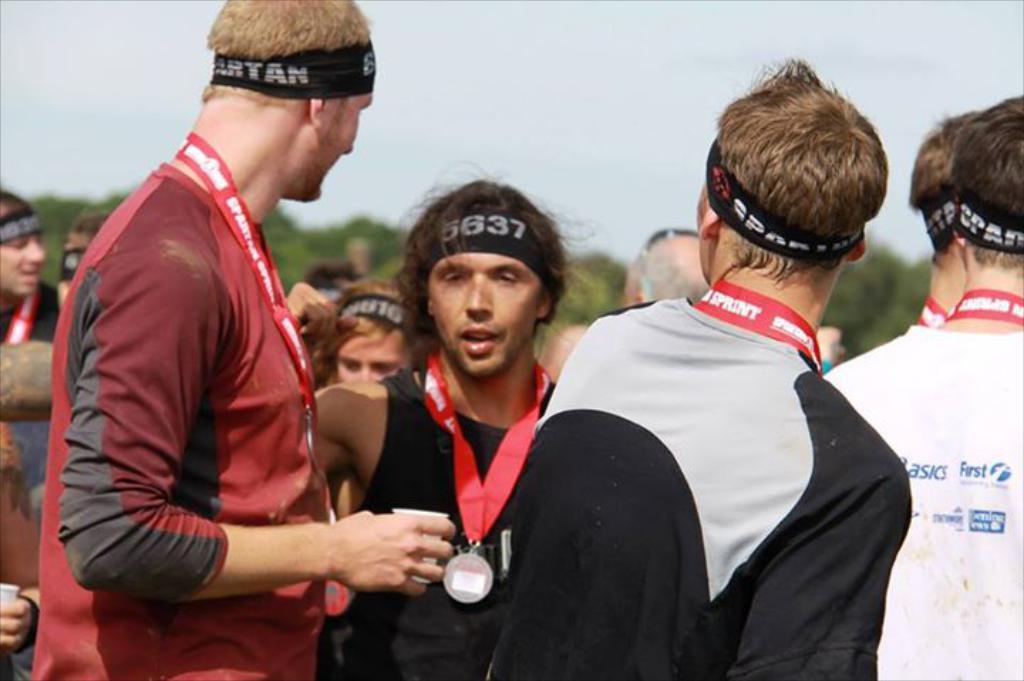Could you give a brief overview of what you see in this image? In the image there are a group of men and they are wearing bands to their heads and also some metals to their necks, the background of the men is blur. 